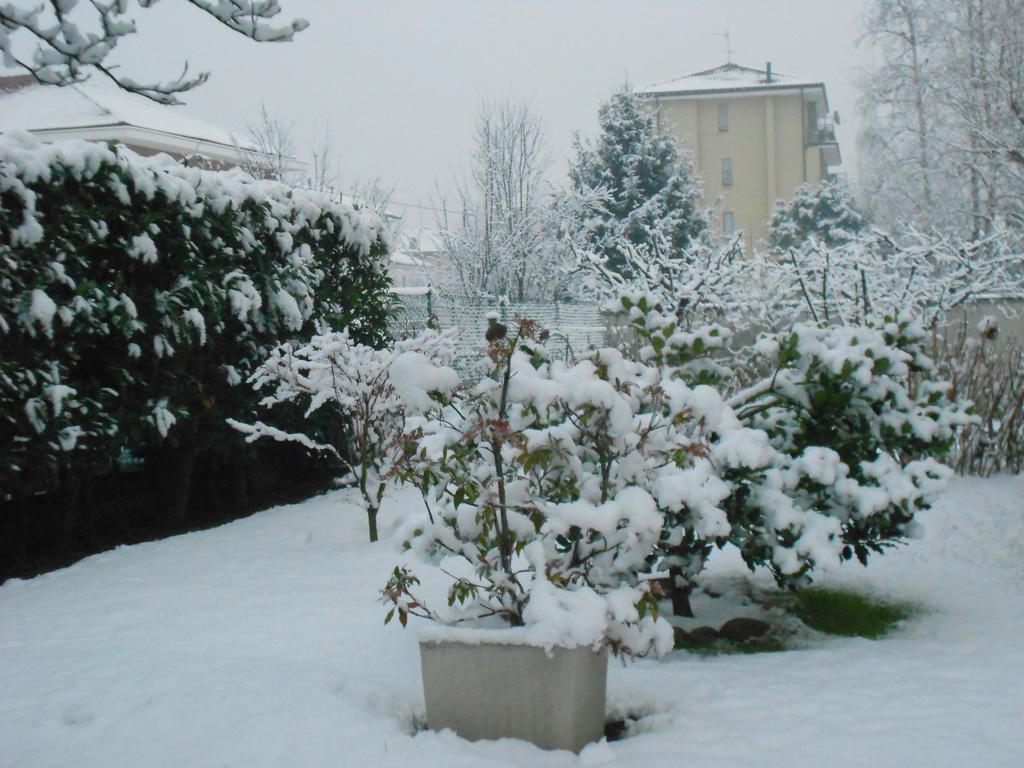Can you describe this image briefly? In the image there are plants in the middle and on left side covered with snow, the land is covered with snow all over the place, in the background there are buildings with trees on either sides with snow on it and above its sky. 